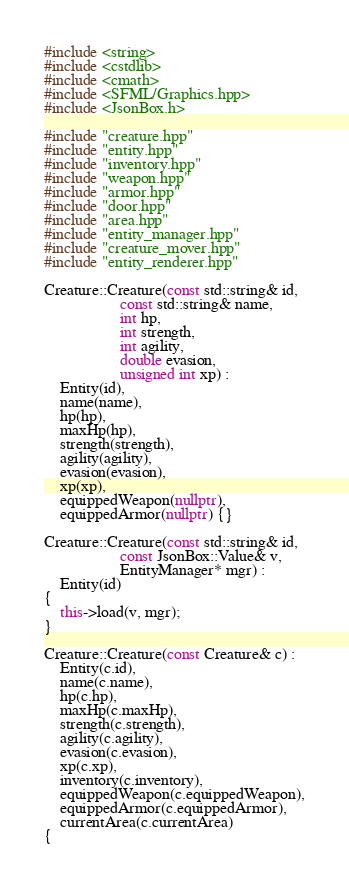Convert code to text. <code><loc_0><loc_0><loc_500><loc_500><_C++_>#include <string>
#include <cstdlib>
#include <cmath>
#include <SFML/Graphics.hpp>
#include <JsonBox.h>

#include "creature.hpp"
#include "entity.hpp"
#include "inventory.hpp"
#include "weapon.hpp"
#include "armor.hpp"
#include "door.hpp"
#include "area.hpp"
#include "entity_manager.hpp"
#include "creature_mover.hpp"
#include "entity_renderer.hpp"

Creature::Creature(const std::string& id,
				   const std::string& name,
				   int hp,
				   int strength,
				   int agility,
				   double evasion,
				   unsigned int xp) :
	Entity(id),
	name(name),
	hp(hp),
	maxHp(hp),
	strength(strength),
	agility(agility),
	evasion(evasion),
	xp(xp),
	equippedWeapon(nullptr),
	equippedArmor(nullptr) {}

Creature::Creature(const std::string& id,
				   const JsonBox::Value& v,
				   EntityManager* mgr) :
	Entity(id)
{
	this->load(v, mgr);
}

Creature::Creature(const Creature& c) :
	Entity(c.id),
	name(c.name),
	hp(c.hp),
	maxHp(c.maxHp),
	strength(c.strength),
	agility(c.agility),
	evasion(c.evasion),
	xp(c.xp), 
	inventory(c.inventory),
	equippedWeapon(c.equippedWeapon),
	equippedArmor(c.equippedArmor),
	currentArea(c.currentArea)
{</code> 